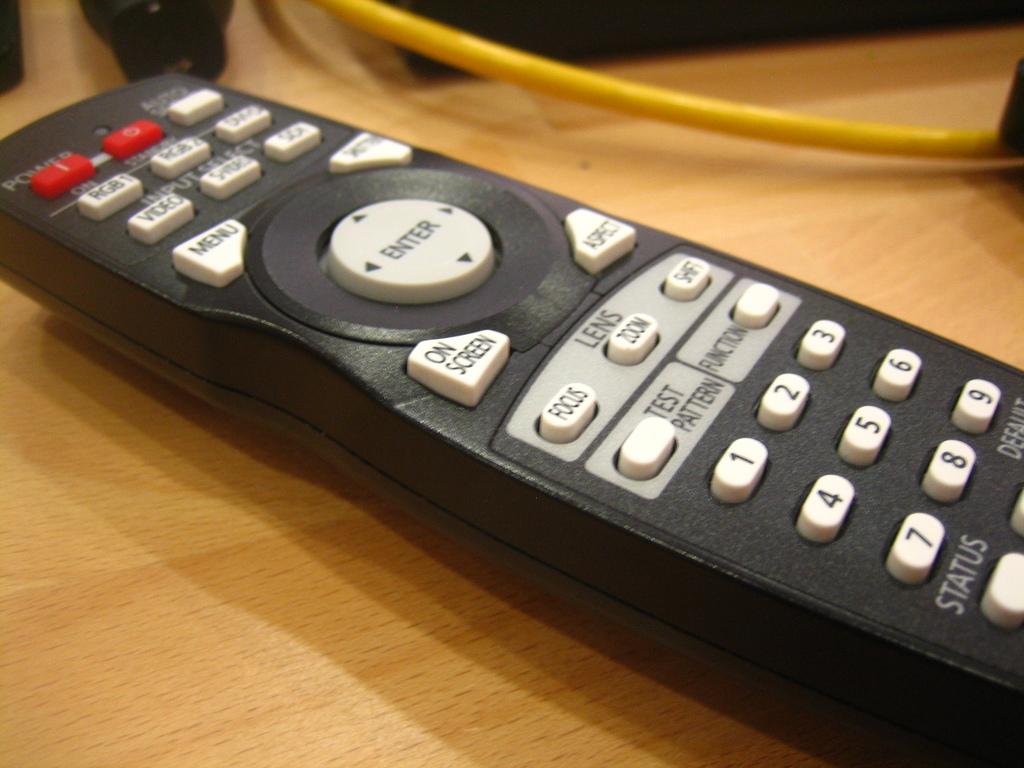What is the center circular button for?
Offer a very short reply. Enter. What is the button below the 7 for?
Give a very brief answer. Status. 